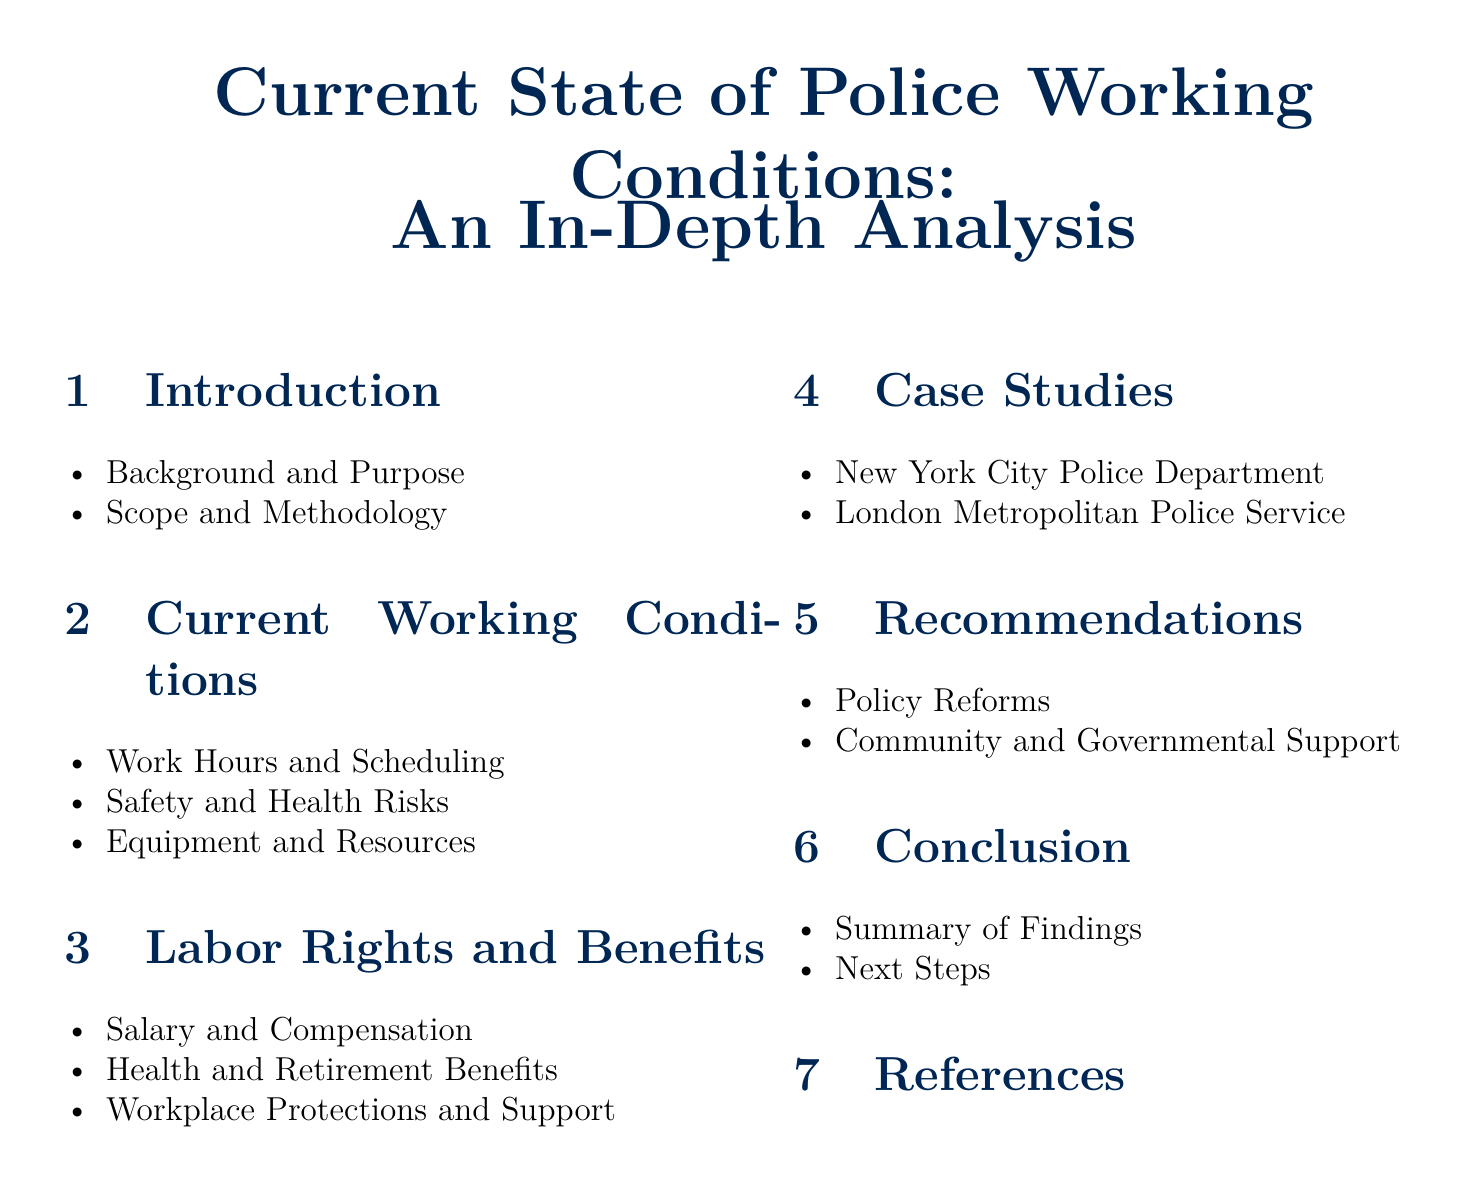what is the title of the document? The title is indicated at the beginning of the document as "Current State of Police Working Conditions: An In-Depth Analysis."
Answer: Current State of Police Working Conditions: An In-Depth Analysis how many sections are in the document? The document contains five main sections listed in the table of contents.
Answer: Five what is the first item listed under Current Working Conditions? The first item listed under this section is "Work Hours and Scheduling."
Answer: Work Hours and Scheduling which police department is studied in the case studies? The case studies include the "New York City Police Department" as one of the examples.
Answer: New York City Police Department what does the Recommendations section focus on? The Recommendations section highlights "Policy Reforms" and "Community and Governmental Support."
Answer: Policy Reforms, Community and Governmental Support what type of benefits are discussed under Labor Rights and Benefits? The section includes discussions on "Health and Retirement Benefits."
Answer: Health and Retirement Benefits what is the last item in the Conclusion section? The last item in the Conclusion section is "Next Steps."
Answer: Next Steps which methodology is mentioned in the Introduction? The methodology is discussed under the sub-item "Scope and Methodology."
Answer: Scope and Methodology 